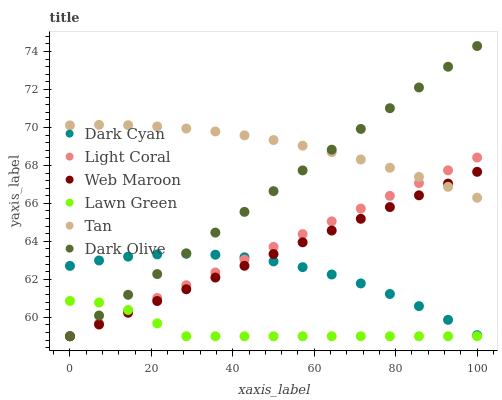Does Lawn Green have the minimum area under the curve?
Answer yes or no. Yes. Does Tan have the maximum area under the curve?
Answer yes or no. Yes. Does Dark Olive have the minimum area under the curve?
Answer yes or no. No. Does Dark Olive have the maximum area under the curve?
Answer yes or no. No. Is Web Maroon the smoothest?
Answer yes or no. Yes. Is Lawn Green the roughest?
Answer yes or no. Yes. Is Dark Olive the smoothest?
Answer yes or no. No. Is Dark Olive the roughest?
Answer yes or no. No. Does Lawn Green have the lowest value?
Answer yes or no. Yes. Does Dark Cyan have the lowest value?
Answer yes or no. No. Does Dark Olive have the highest value?
Answer yes or no. Yes. Does Web Maroon have the highest value?
Answer yes or no. No. Is Lawn Green less than Tan?
Answer yes or no. Yes. Is Tan greater than Lawn Green?
Answer yes or no. Yes. Does Dark Olive intersect Light Coral?
Answer yes or no. Yes. Is Dark Olive less than Light Coral?
Answer yes or no. No. Is Dark Olive greater than Light Coral?
Answer yes or no. No. Does Lawn Green intersect Tan?
Answer yes or no. No. 